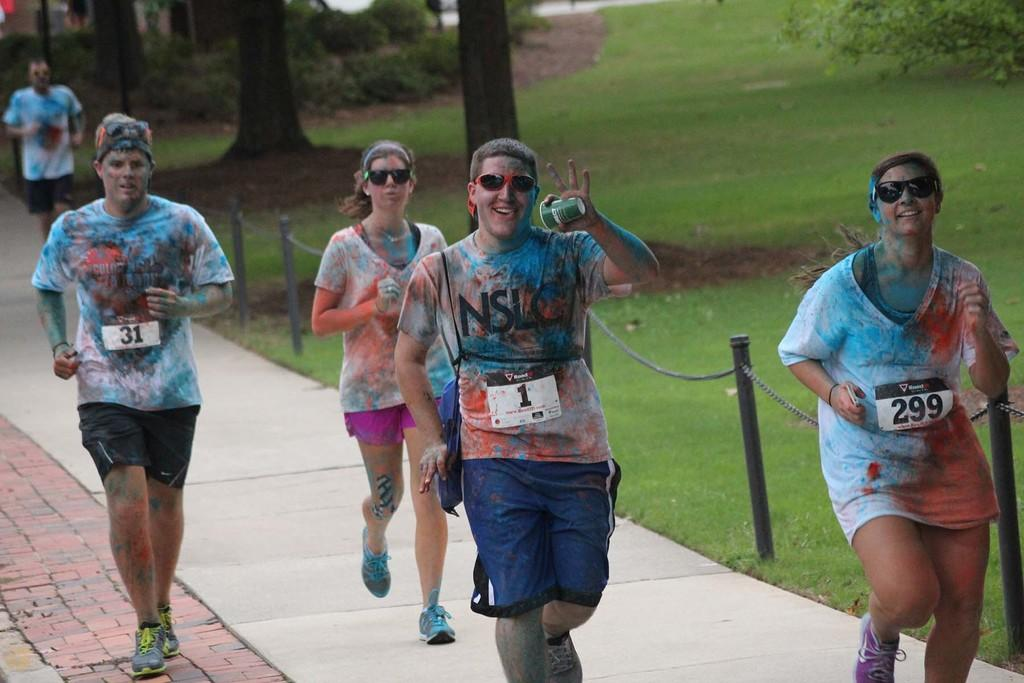How many people are in the image? There is a group of people in the image. What are the people in the image doing? The people are running on the ground. What can be seen in the image besides the people? There is a fence and grass visible in the image. What is visible in the background of the image? There are trees in the background of the image. What type of company is conducting trade in the image? There is no company or trade present in the image; it features a group of people running on the ground with a fence, grass, and trees in the background. 